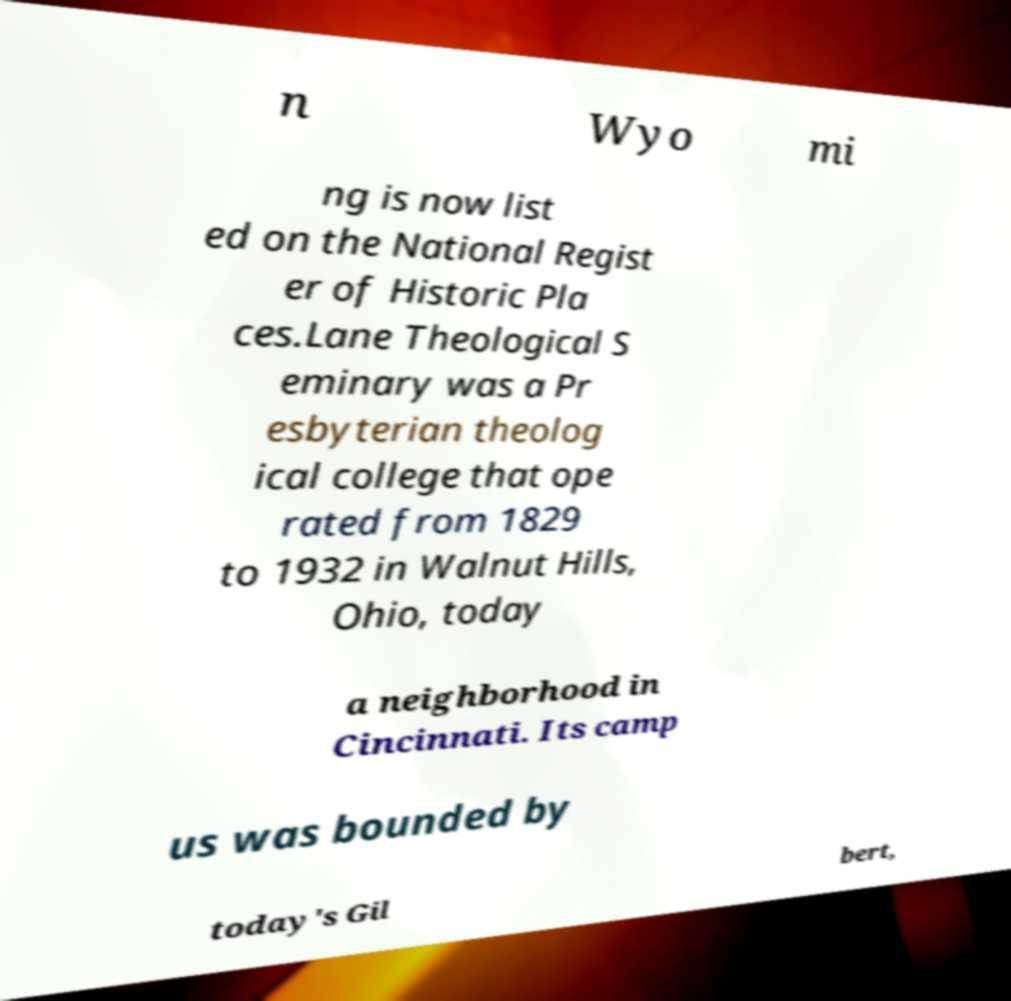What messages or text are displayed in this image? I need them in a readable, typed format. n Wyo mi ng is now list ed on the National Regist er of Historic Pla ces.Lane Theological S eminary was a Pr esbyterian theolog ical college that ope rated from 1829 to 1932 in Walnut Hills, Ohio, today a neighborhood in Cincinnati. Its camp us was bounded by today's Gil bert, 